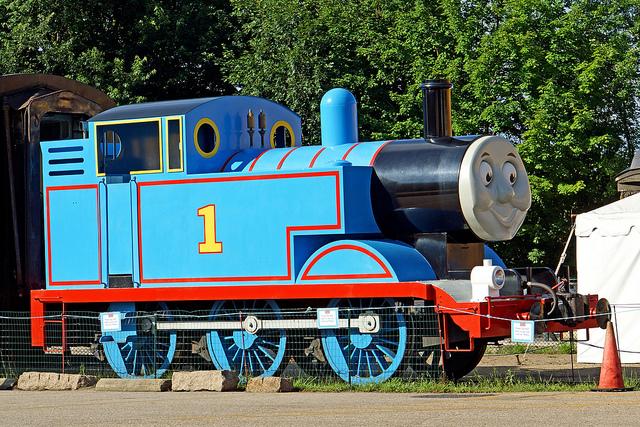How many safety cones are in the photo?
Answer briefly. 1. Is this an antique?
Answer briefly. No. What number do you see?
Answer briefly. 1. What is the name of the train?
Write a very short answer. Thomas. Is this train engine covered in rust?
Quick response, please. No. What color is this train?
Quick response, please. Blue. What numbers does this train have on it?
Write a very short answer. 1. Is the train on the tracks?
Short answer required. No. Are there any people in the scene?
Write a very short answer. No. Is this train on the tracks?
Give a very brief answer. No. What color is the train?
Write a very short answer. Blue. How many light rimmed wheels are shown?
Concise answer only. 3. Does the train have a face?
Keep it brief. Yes. Is the train black?
Quick response, please. No. What number is on the train?
Short answer required. 1. 